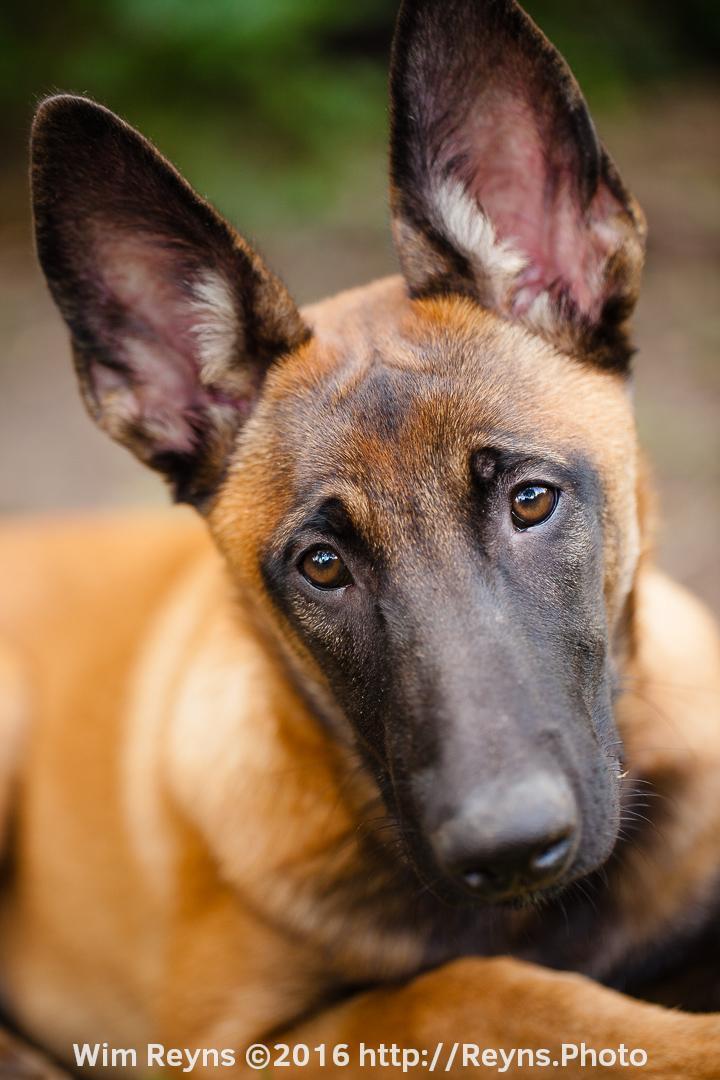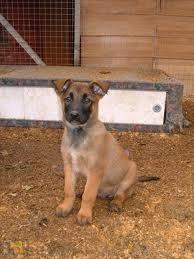The first image is the image on the left, the second image is the image on the right. Given the left and right images, does the statement "In at least one image the dog is not looking toward the camera." hold true? Answer yes or no. No. The first image is the image on the left, the second image is the image on the right. Assess this claim about the two images: "One dog is looking up.". Correct or not? Answer yes or no. No. 